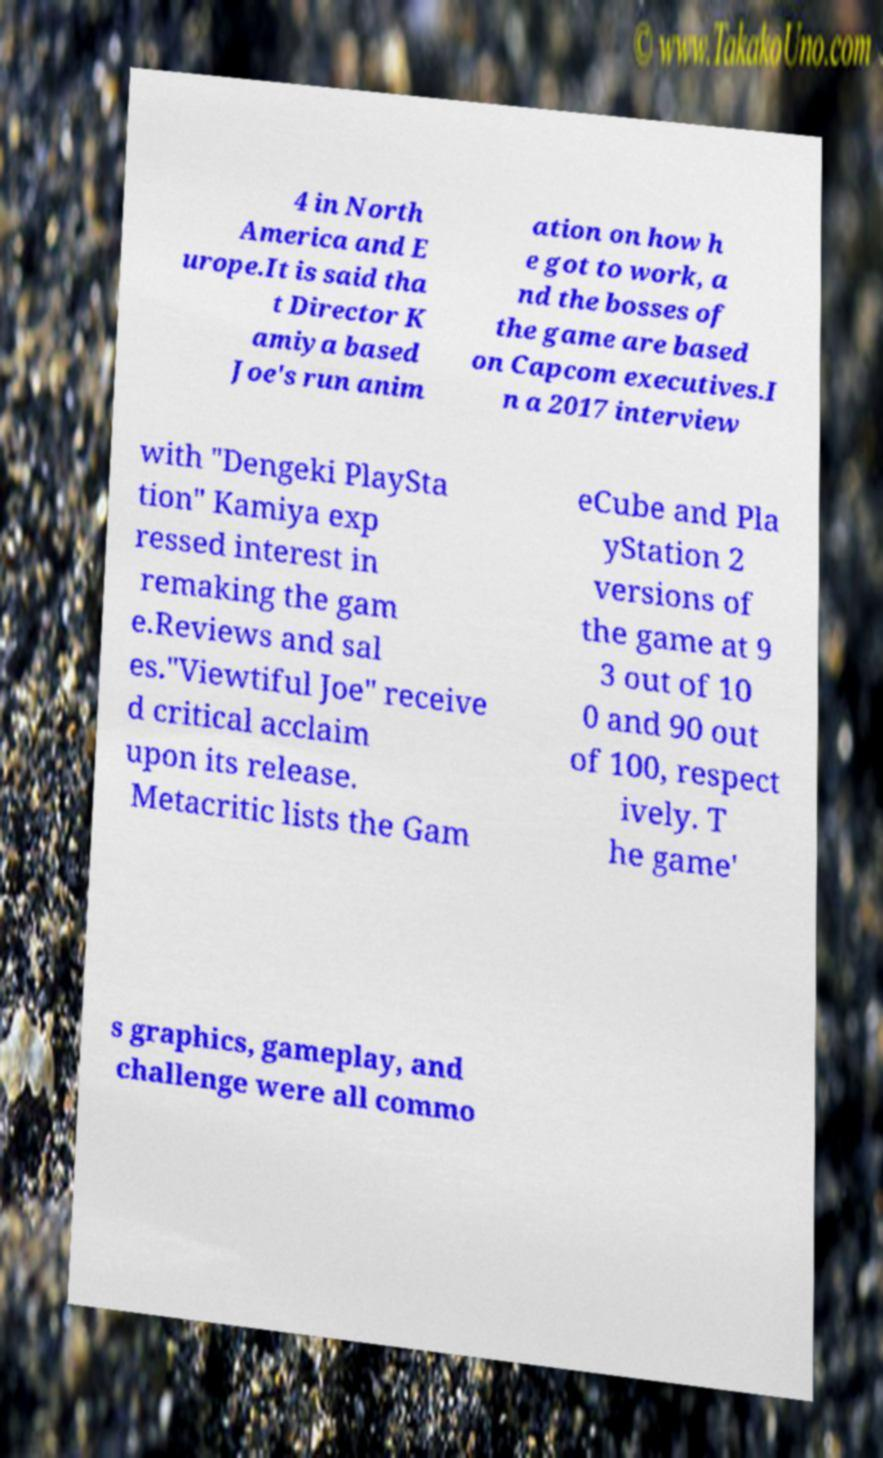Could you extract and type out the text from this image? 4 in North America and E urope.It is said tha t Director K amiya based Joe's run anim ation on how h e got to work, a nd the bosses of the game are based on Capcom executives.I n a 2017 interview with "Dengeki PlaySta tion" Kamiya exp ressed interest in remaking the gam e.Reviews and sal es."Viewtiful Joe" receive d critical acclaim upon its release. Metacritic lists the Gam eCube and Pla yStation 2 versions of the game at 9 3 out of 10 0 and 90 out of 100, respect ively. T he game' s graphics, gameplay, and challenge were all commo 